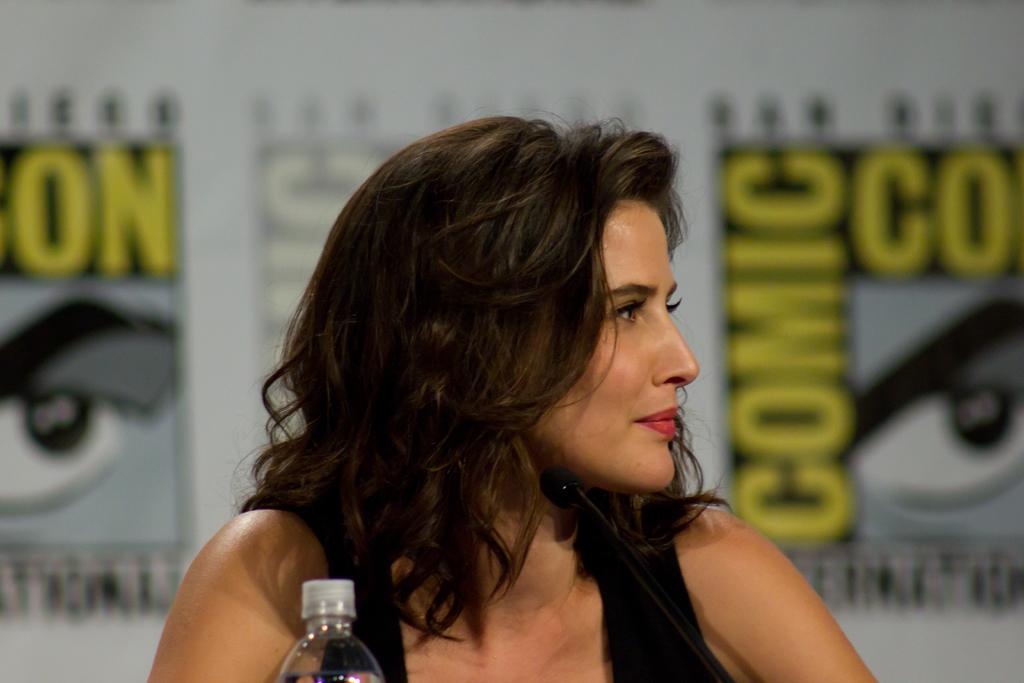Who is the main subject in the image? There is a lady in the image. What objects are in front of the lady? There is a bottle and a mic in front of the lady. What can be seen behind the lady? There is a poster with text and images behind the lady. How would you describe the background of the image? The background is blurred. What type of tent can be seen in the image? There is no tent present in the image. What part of the lady's body is exposed in the image? The image does not show any exposed flesh; the lady is fully clothed. 